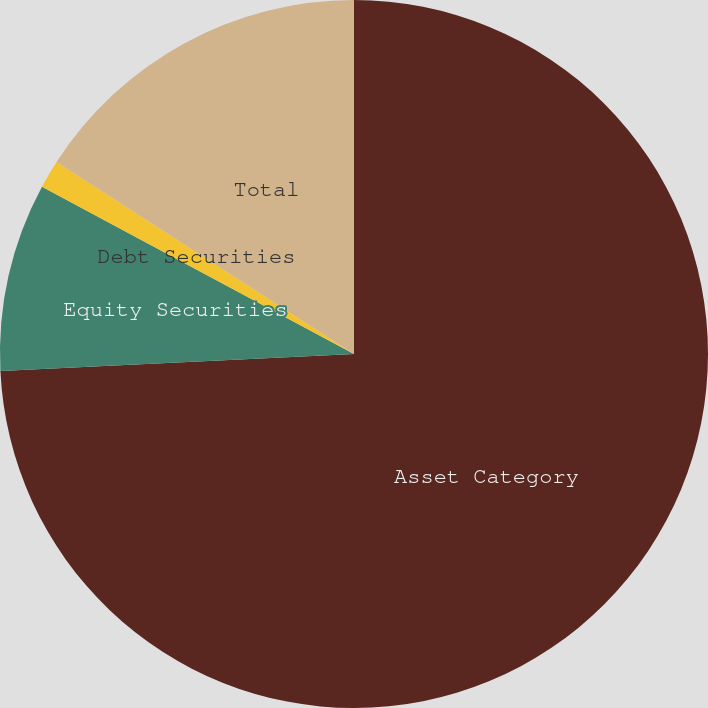<chart> <loc_0><loc_0><loc_500><loc_500><pie_chart><fcel>Asset Category<fcel>Equity Securities<fcel>Debt Securities<fcel>Total<nl><fcel>74.23%<fcel>8.59%<fcel>1.29%<fcel>15.88%<nl></chart> 